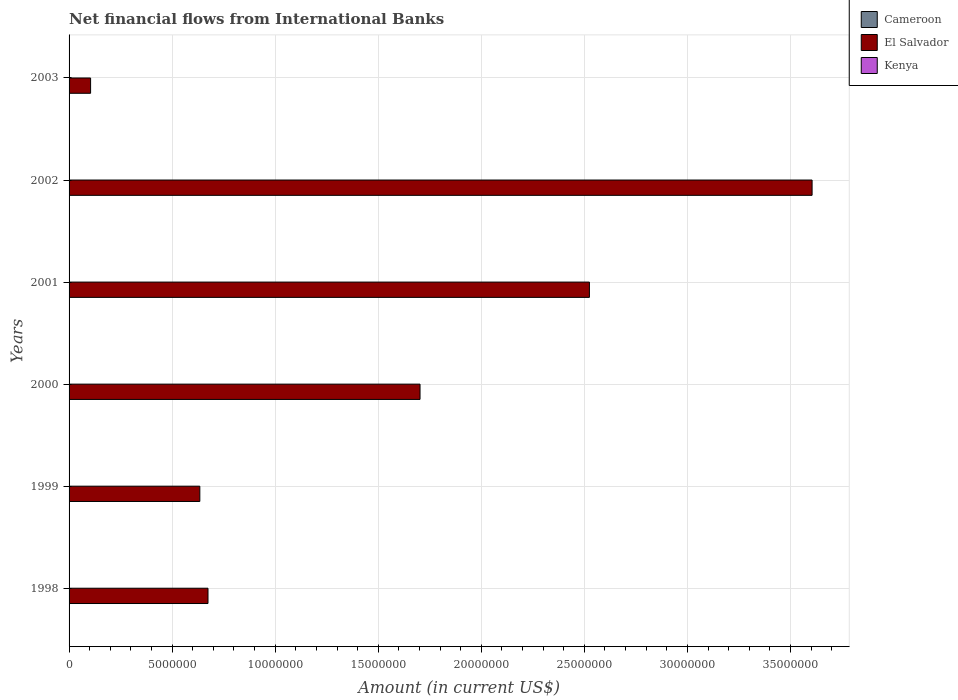How many different coloured bars are there?
Offer a terse response. 1. Are the number of bars on each tick of the Y-axis equal?
Make the answer very short. Yes. How many bars are there on the 2nd tick from the top?
Give a very brief answer. 1. How many bars are there on the 4th tick from the bottom?
Your response must be concise. 1. In how many cases, is the number of bars for a given year not equal to the number of legend labels?
Provide a succinct answer. 6. What is the net financial aid flows in El Salvador in 2002?
Offer a very short reply. 3.60e+07. Across all years, what is the maximum net financial aid flows in El Salvador?
Your answer should be very brief. 3.60e+07. Across all years, what is the minimum net financial aid flows in El Salvador?
Give a very brief answer. 1.04e+06. What is the total net financial aid flows in El Salvador in the graph?
Give a very brief answer. 9.24e+07. What is the difference between the net financial aid flows in El Salvador in 2000 and that in 2003?
Make the answer very short. 1.60e+07. What is the difference between the net financial aid flows in Kenya in 2000 and the net financial aid flows in Cameroon in 1998?
Offer a very short reply. 0. What is the average net financial aid flows in Kenya per year?
Give a very brief answer. 0. In how many years, is the net financial aid flows in Cameroon greater than 27000000 US$?
Make the answer very short. 0. What is the ratio of the net financial aid flows in El Salvador in 1998 to that in 2000?
Keep it short and to the point. 0.4. Is the net financial aid flows in El Salvador in 2001 less than that in 2002?
Offer a terse response. Yes. What is the difference between the highest and the second highest net financial aid flows in El Salvador?
Keep it short and to the point. 1.08e+07. What is the difference between the highest and the lowest net financial aid flows in El Salvador?
Your answer should be compact. 3.50e+07. In how many years, is the net financial aid flows in Cameroon greater than the average net financial aid flows in Cameroon taken over all years?
Your answer should be compact. 0. Is the sum of the net financial aid flows in El Salvador in 1998 and 2001 greater than the maximum net financial aid flows in Kenya across all years?
Provide a succinct answer. Yes. How many bars are there?
Keep it short and to the point. 6. Does the graph contain grids?
Give a very brief answer. Yes. Where does the legend appear in the graph?
Offer a terse response. Top right. What is the title of the graph?
Provide a short and direct response. Net financial flows from International Banks. What is the label or title of the X-axis?
Give a very brief answer. Amount (in current US$). What is the label or title of the Y-axis?
Your answer should be very brief. Years. What is the Amount (in current US$) in El Salvador in 1998?
Your answer should be compact. 6.74e+06. What is the Amount (in current US$) of Kenya in 1998?
Provide a short and direct response. 0. What is the Amount (in current US$) in Cameroon in 1999?
Offer a terse response. 0. What is the Amount (in current US$) of El Salvador in 1999?
Provide a succinct answer. 6.34e+06. What is the Amount (in current US$) in Kenya in 1999?
Ensure brevity in your answer.  0. What is the Amount (in current US$) in El Salvador in 2000?
Provide a succinct answer. 1.70e+07. What is the Amount (in current US$) of Cameroon in 2001?
Provide a succinct answer. 0. What is the Amount (in current US$) of El Salvador in 2001?
Provide a succinct answer. 2.52e+07. What is the Amount (in current US$) of Kenya in 2001?
Provide a succinct answer. 0. What is the Amount (in current US$) of Cameroon in 2002?
Make the answer very short. 0. What is the Amount (in current US$) of El Salvador in 2002?
Keep it short and to the point. 3.60e+07. What is the Amount (in current US$) in Kenya in 2002?
Your response must be concise. 0. What is the Amount (in current US$) of Cameroon in 2003?
Your answer should be very brief. 0. What is the Amount (in current US$) in El Salvador in 2003?
Offer a terse response. 1.04e+06. What is the Amount (in current US$) in Kenya in 2003?
Keep it short and to the point. 0. Across all years, what is the maximum Amount (in current US$) in El Salvador?
Give a very brief answer. 3.60e+07. Across all years, what is the minimum Amount (in current US$) in El Salvador?
Your answer should be compact. 1.04e+06. What is the total Amount (in current US$) of Cameroon in the graph?
Provide a short and direct response. 0. What is the total Amount (in current US$) in El Salvador in the graph?
Keep it short and to the point. 9.24e+07. What is the total Amount (in current US$) of Kenya in the graph?
Keep it short and to the point. 0. What is the difference between the Amount (in current US$) of El Salvador in 1998 and that in 1999?
Give a very brief answer. 3.96e+05. What is the difference between the Amount (in current US$) of El Salvador in 1998 and that in 2000?
Make the answer very short. -1.03e+07. What is the difference between the Amount (in current US$) in El Salvador in 1998 and that in 2001?
Your answer should be compact. -1.85e+07. What is the difference between the Amount (in current US$) in El Salvador in 1998 and that in 2002?
Offer a very short reply. -2.93e+07. What is the difference between the Amount (in current US$) of El Salvador in 1998 and that in 2003?
Provide a succinct answer. 5.70e+06. What is the difference between the Amount (in current US$) of El Salvador in 1999 and that in 2000?
Keep it short and to the point. -1.07e+07. What is the difference between the Amount (in current US$) in El Salvador in 1999 and that in 2001?
Provide a succinct answer. -1.89e+07. What is the difference between the Amount (in current US$) of El Salvador in 1999 and that in 2002?
Give a very brief answer. -2.97e+07. What is the difference between the Amount (in current US$) in El Salvador in 1999 and that in 2003?
Ensure brevity in your answer.  5.30e+06. What is the difference between the Amount (in current US$) in El Salvador in 2000 and that in 2001?
Provide a short and direct response. -8.22e+06. What is the difference between the Amount (in current US$) of El Salvador in 2000 and that in 2002?
Your answer should be compact. -1.90e+07. What is the difference between the Amount (in current US$) of El Salvador in 2000 and that in 2003?
Keep it short and to the point. 1.60e+07. What is the difference between the Amount (in current US$) in El Salvador in 2001 and that in 2002?
Give a very brief answer. -1.08e+07. What is the difference between the Amount (in current US$) of El Salvador in 2001 and that in 2003?
Ensure brevity in your answer.  2.42e+07. What is the difference between the Amount (in current US$) in El Salvador in 2002 and that in 2003?
Provide a short and direct response. 3.50e+07. What is the average Amount (in current US$) of Cameroon per year?
Provide a short and direct response. 0. What is the average Amount (in current US$) in El Salvador per year?
Your response must be concise. 1.54e+07. What is the average Amount (in current US$) in Kenya per year?
Give a very brief answer. 0. What is the ratio of the Amount (in current US$) in El Salvador in 1998 to that in 1999?
Offer a terse response. 1.06. What is the ratio of the Amount (in current US$) in El Salvador in 1998 to that in 2000?
Offer a very short reply. 0.4. What is the ratio of the Amount (in current US$) of El Salvador in 1998 to that in 2001?
Provide a short and direct response. 0.27. What is the ratio of the Amount (in current US$) of El Salvador in 1998 to that in 2002?
Make the answer very short. 0.19. What is the ratio of the Amount (in current US$) in El Salvador in 1998 to that in 2003?
Your answer should be very brief. 6.46. What is the ratio of the Amount (in current US$) of El Salvador in 1999 to that in 2000?
Offer a very short reply. 0.37. What is the ratio of the Amount (in current US$) of El Salvador in 1999 to that in 2001?
Keep it short and to the point. 0.25. What is the ratio of the Amount (in current US$) in El Salvador in 1999 to that in 2002?
Your response must be concise. 0.18. What is the ratio of the Amount (in current US$) in El Salvador in 1999 to that in 2003?
Provide a succinct answer. 6.08. What is the ratio of the Amount (in current US$) in El Salvador in 2000 to that in 2001?
Your response must be concise. 0.67. What is the ratio of the Amount (in current US$) in El Salvador in 2000 to that in 2002?
Your answer should be very brief. 0.47. What is the ratio of the Amount (in current US$) in El Salvador in 2000 to that in 2003?
Keep it short and to the point. 16.31. What is the ratio of the Amount (in current US$) of El Salvador in 2001 to that in 2002?
Provide a succinct answer. 0.7. What is the ratio of the Amount (in current US$) of El Salvador in 2001 to that in 2003?
Make the answer very short. 24.18. What is the ratio of the Amount (in current US$) in El Salvador in 2002 to that in 2003?
Provide a short and direct response. 34.53. What is the difference between the highest and the second highest Amount (in current US$) of El Salvador?
Keep it short and to the point. 1.08e+07. What is the difference between the highest and the lowest Amount (in current US$) in El Salvador?
Offer a very short reply. 3.50e+07. 